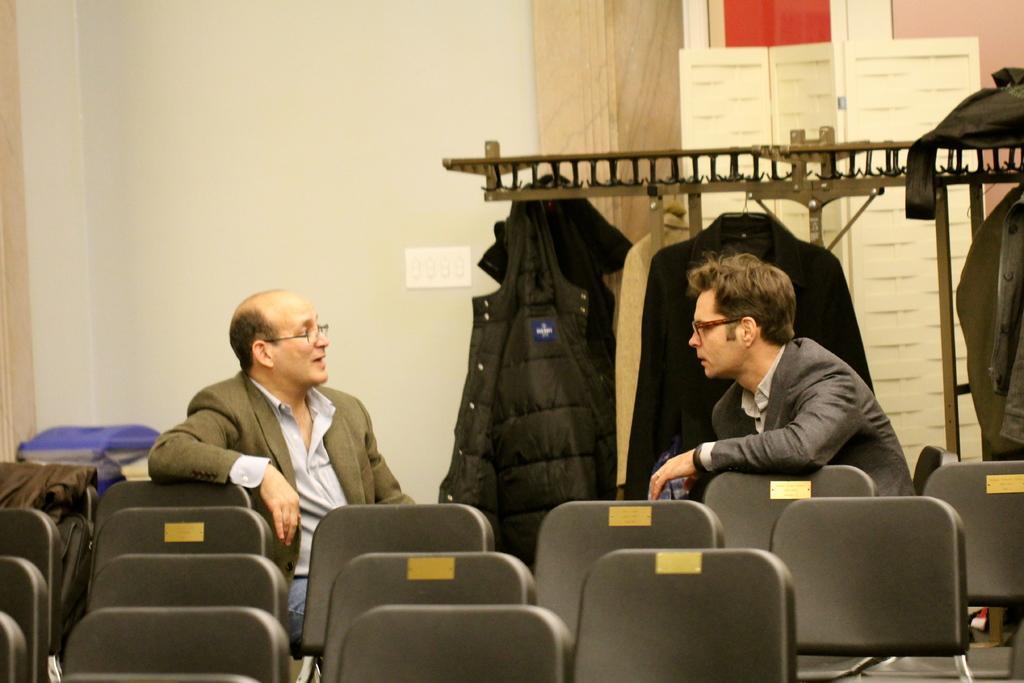Can you describe this image briefly? In a room there are so many chairs and two people are sitting and talking behind them there is a hanger and clothes hanging to them. 